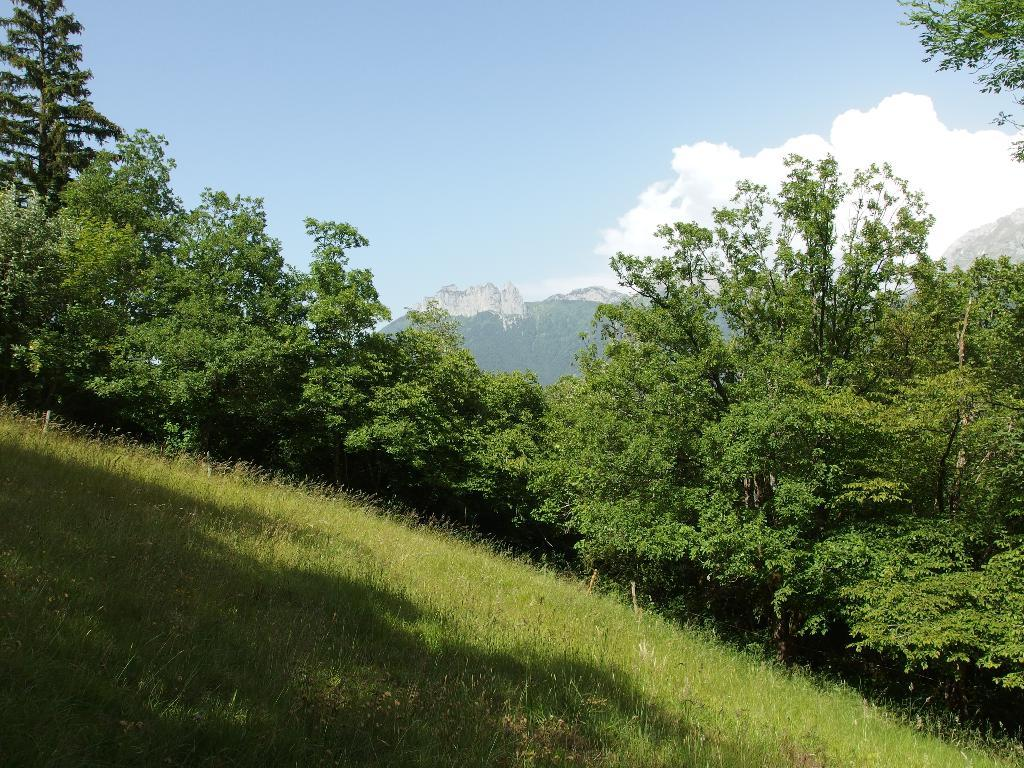What type of landscape is depicted in the image? The image features hills and trees. What type of vegetation is present at the bottom of the image? There is grass at the bottom of the image. What can be seen in the sky at the top of the image? There are clouds in the sky at the top of the image. How many sticks are being used to create a limit in the image? There are no sticks or limits present in the image. 